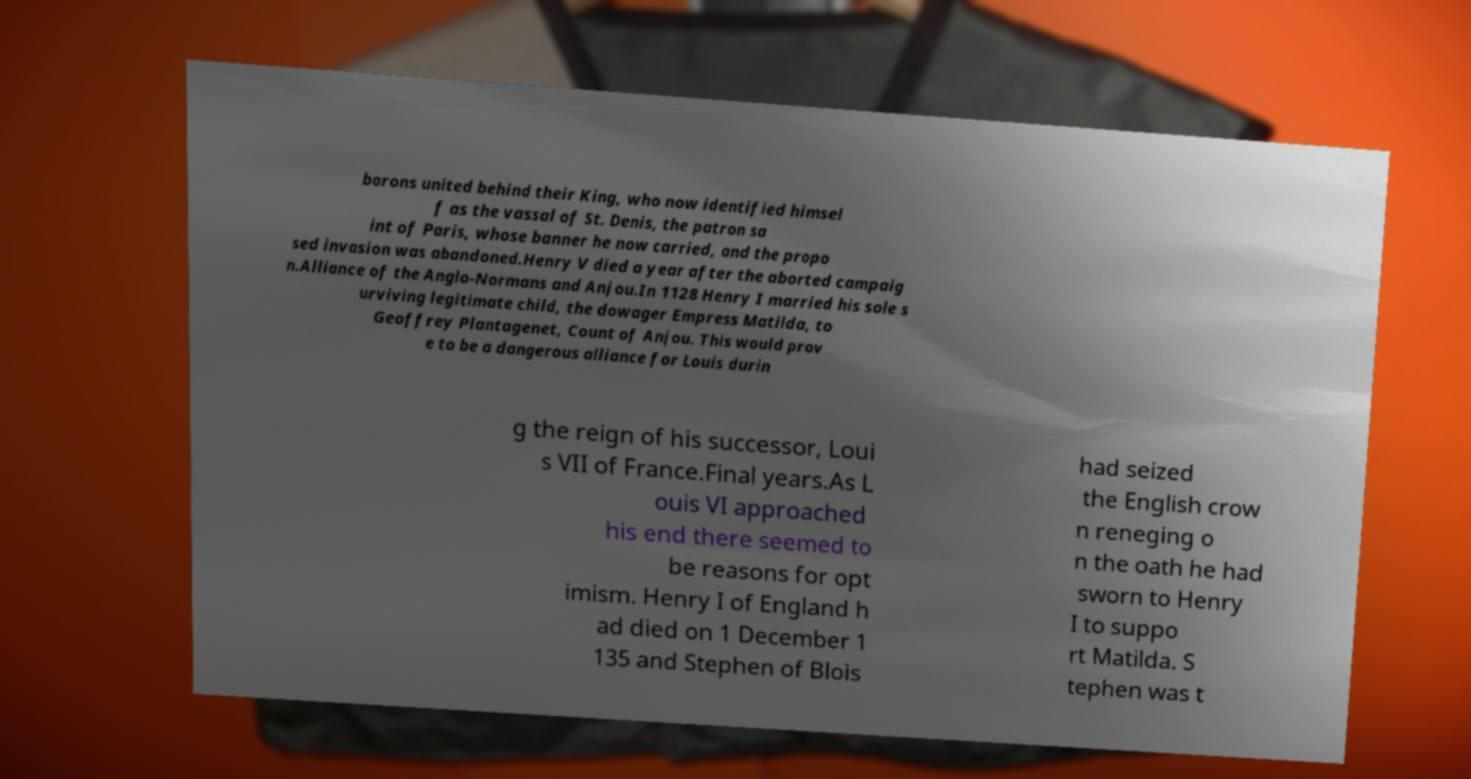Could you extract and type out the text from this image? barons united behind their King, who now identified himsel f as the vassal of St. Denis, the patron sa int of Paris, whose banner he now carried, and the propo sed invasion was abandoned.Henry V died a year after the aborted campaig n.Alliance of the Anglo-Normans and Anjou.In 1128 Henry I married his sole s urviving legitimate child, the dowager Empress Matilda, to Geoffrey Plantagenet, Count of Anjou. This would prov e to be a dangerous alliance for Louis durin g the reign of his successor, Loui s VII of France.Final years.As L ouis VI approached his end there seemed to be reasons for opt imism. Henry I of England h ad died on 1 December 1 135 and Stephen of Blois had seized the English crow n reneging o n the oath he had sworn to Henry I to suppo rt Matilda. S tephen was t 